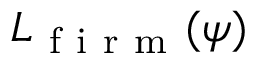<formula> <loc_0><loc_0><loc_500><loc_500>{ L } _ { f i r m } ( \psi )</formula> 